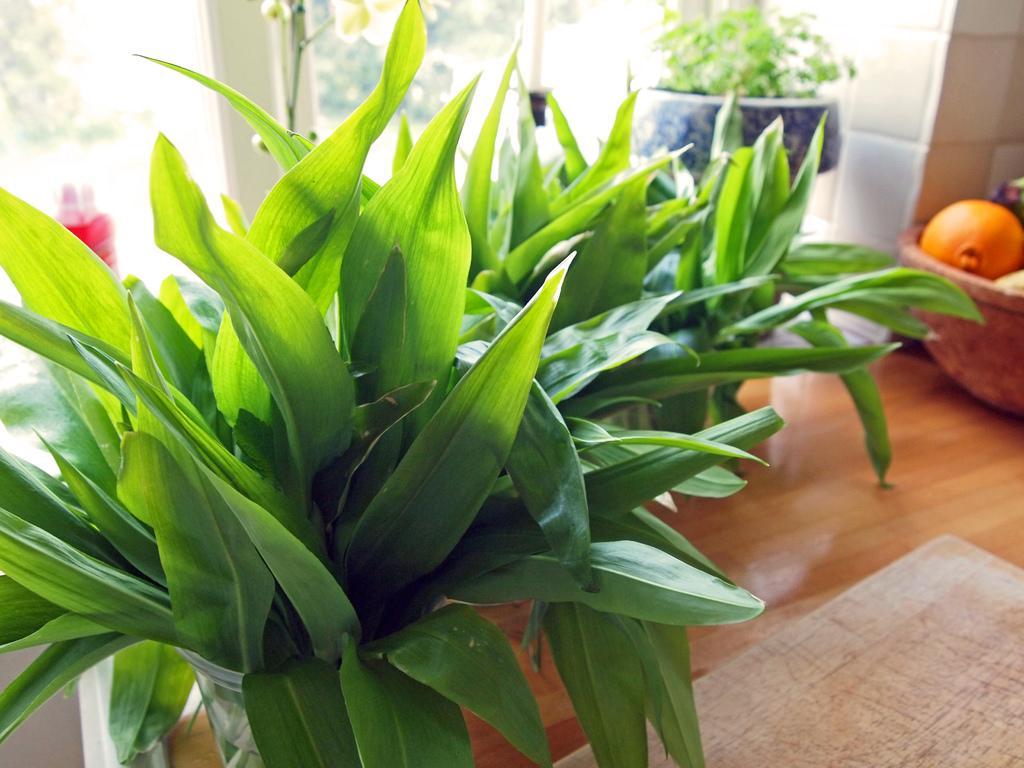How would you summarize this image in a sentence or two? In this image we can see group of plants placed in container on the table. To the right side of the image we can see group of vegetable place in a bowl. In the background we can see a window and a bottle. 